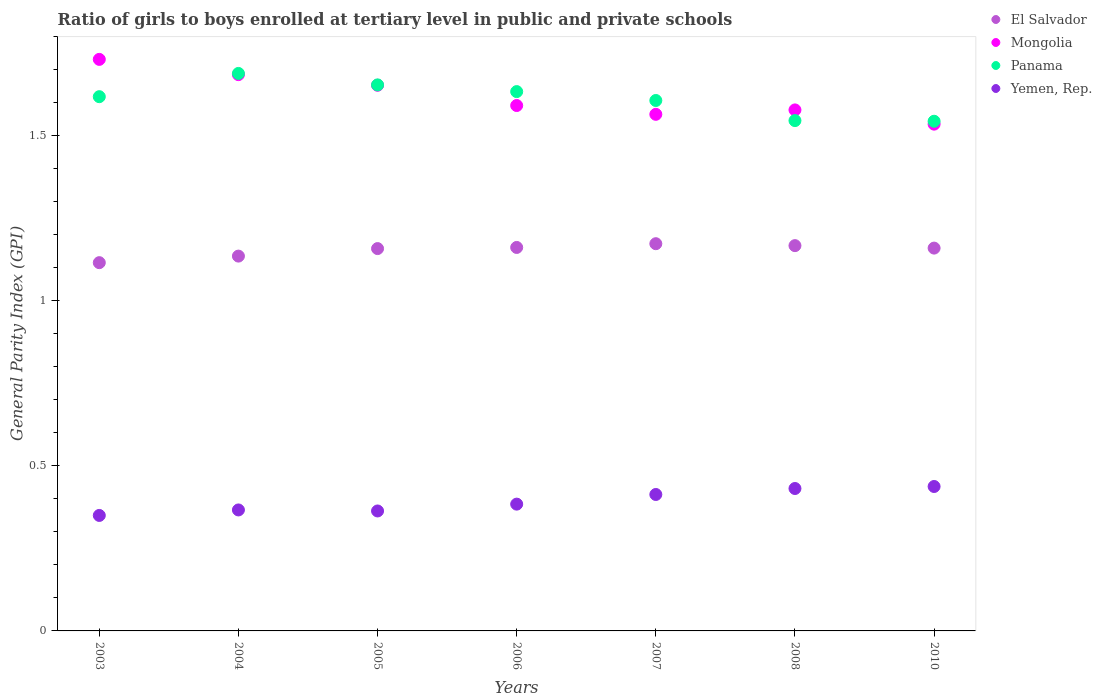How many different coloured dotlines are there?
Keep it short and to the point. 4. What is the general parity index in Panama in 2004?
Offer a terse response. 1.69. Across all years, what is the maximum general parity index in Panama?
Ensure brevity in your answer.  1.69. Across all years, what is the minimum general parity index in Panama?
Provide a short and direct response. 1.54. In which year was the general parity index in El Salvador maximum?
Keep it short and to the point. 2007. What is the total general parity index in Yemen, Rep. in the graph?
Offer a very short reply. 2.75. What is the difference between the general parity index in El Salvador in 2004 and that in 2010?
Offer a terse response. -0.02. What is the difference between the general parity index in Mongolia in 2006 and the general parity index in Panama in 2008?
Ensure brevity in your answer.  0.05. What is the average general parity index in Mongolia per year?
Your answer should be compact. 1.62. In the year 2006, what is the difference between the general parity index in Yemen, Rep. and general parity index in El Salvador?
Your answer should be compact. -0.78. In how many years, is the general parity index in El Salvador greater than 0.2?
Offer a very short reply. 7. What is the ratio of the general parity index in El Salvador in 2003 to that in 2007?
Provide a succinct answer. 0.95. Is the general parity index in Mongolia in 2004 less than that in 2008?
Your answer should be compact. No. What is the difference between the highest and the second highest general parity index in El Salvador?
Ensure brevity in your answer.  0.01. What is the difference between the highest and the lowest general parity index in Mongolia?
Keep it short and to the point. 0.2. Is the sum of the general parity index in El Salvador in 2004 and 2010 greater than the maximum general parity index in Mongolia across all years?
Your answer should be compact. Yes. Is the general parity index in Yemen, Rep. strictly less than the general parity index in El Salvador over the years?
Keep it short and to the point. Yes. How many dotlines are there?
Ensure brevity in your answer.  4. How many years are there in the graph?
Provide a short and direct response. 7. How many legend labels are there?
Provide a succinct answer. 4. How are the legend labels stacked?
Your response must be concise. Vertical. What is the title of the graph?
Your answer should be very brief. Ratio of girls to boys enrolled at tertiary level in public and private schools. Does "Liberia" appear as one of the legend labels in the graph?
Your answer should be compact. No. What is the label or title of the X-axis?
Make the answer very short. Years. What is the label or title of the Y-axis?
Offer a terse response. General Parity Index (GPI). What is the General Parity Index (GPI) of El Salvador in 2003?
Make the answer very short. 1.12. What is the General Parity Index (GPI) of Mongolia in 2003?
Offer a terse response. 1.73. What is the General Parity Index (GPI) of Panama in 2003?
Offer a terse response. 1.62. What is the General Parity Index (GPI) of Yemen, Rep. in 2003?
Make the answer very short. 0.35. What is the General Parity Index (GPI) in El Salvador in 2004?
Your answer should be compact. 1.14. What is the General Parity Index (GPI) in Mongolia in 2004?
Keep it short and to the point. 1.69. What is the General Parity Index (GPI) of Panama in 2004?
Give a very brief answer. 1.69. What is the General Parity Index (GPI) in Yemen, Rep. in 2004?
Provide a short and direct response. 0.37. What is the General Parity Index (GPI) of El Salvador in 2005?
Make the answer very short. 1.16. What is the General Parity Index (GPI) in Mongolia in 2005?
Offer a terse response. 1.65. What is the General Parity Index (GPI) in Panama in 2005?
Your answer should be very brief. 1.65. What is the General Parity Index (GPI) of Yemen, Rep. in 2005?
Your answer should be very brief. 0.36. What is the General Parity Index (GPI) of El Salvador in 2006?
Your answer should be compact. 1.16. What is the General Parity Index (GPI) in Mongolia in 2006?
Keep it short and to the point. 1.59. What is the General Parity Index (GPI) in Panama in 2006?
Give a very brief answer. 1.63. What is the General Parity Index (GPI) of Yemen, Rep. in 2006?
Your answer should be very brief. 0.38. What is the General Parity Index (GPI) in El Salvador in 2007?
Offer a very short reply. 1.17. What is the General Parity Index (GPI) in Mongolia in 2007?
Keep it short and to the point. 1.56. What is the General Parity Index (GPI) in Panama in 2007?
Your response must be concise. 1.61. What is the General Parity Index (GPI) in Yemen, Rep. in 2007?
Offer a terse response. 0.41. What is the General Parity Index (GPI) of El Salvador in 2008?
Offer a terse response. 1.17. What is the General Parity Index (GPI) of Mongolia in 2008?
Ensure brevity in your answer.  1.58. What is the General Parity Index (GPI) in Panama in 2008?
Provide a succinct answer. 1.55. What is the General Parity Index (GPI) in Yemen, Rep. in 2008?
Your answer should be compact. 0.43. What is the General Parity Index (GPI) in El Salvador in 2010?
Give a very brief answer. 1.16. What is the General Parity Index (GPI) in Mongolia in 2010?
Keep it short and to the point. 1.54. What is the General Parity Index (GPI) in Panama in 2010?
Your answer should be very brief. 1.54. What is the General Parity Index (GPI) in Yemen, Rep. in 2010?
Your answer should be very brief. 0.44. Across all years, what is the maximum General Parity Index (GPI) in El Salvador?
Provide a succinct answer. 1.17. Across all years, what is the maximum General Parity Index (GPI) in Mongolia?
Your answer should be very brief. 1.73. Across all years, what is the maximum General Parity Index (GPI) in Panama?
Keep it short and to the point. 1.69. Across all years, what is the maximum General Parity Index (GPI) in Yemen, Rep.?
Provide a short and direct response. 0.44. Across all years, what is the minimum General Parity Index (GPI) of El Salvador?
Offer a terse response. 1.12. Across all years, what is the minimum General Parity Index (GPI) in Mongolia?
Provide a short and direct response. 1.54. Across all years, what is the minimum General Parity Index (GPI) in Panama?
Your answer should be very brief. 1.54. Across all years, what is the minimum General Parity Index (GPI) of Yemen, Rep.?
Give a very brief answer. 0.35. What is the total General Parity Index (GPI) of El Salvador in the graph?
Make the answer very short. 8.07. What is the total General Parity Index (GPI) of Mongolia in the graph?
Make the answer very short. 11.34. What is the total General Parity Index (GPI) in Panama in the graph?
Offer a terse response. 11.29. What is the total General Parity Index (GPI) of Yemen, Rep. in the graph?
Offer a very short reply. 2.75. What is the difference between the General Parity Index (GPI) in El Salvador in 2003 and that in 2004?
Give a very brief answer. -0.02. What is the difference between the General Parity Index (GPI) of Mongolia in 2003 and that in 2004?
Keep it short and to the point. 0.05. What is the difference between the General Parity Index (GPI) in Panama in 2003 and that in 2004?
Your answer should be very brief. -0.07. What is the difference between the General Parity Index (GPI) in Yemen, Rep. in 2003 and that in 2004?
Provide a succinct answer. -0.02. What is the difference between the General Parity Index (GPI) in El Salvador in 2003 and that in 2005?
Keep it short and to the point. -0.04. What is the difference between the General Parity Index (GPI) in Mongolia in 2003 and that in 2005?
Give a very brief answer. 0.08. What is the difference between the General Parity Index (GPI) in Panama in 2003 and that in 2005?
Give a very brief answer. -0.04. What is the difference between the General Parity Index (GPI) of Yemen, Rep. in 2003 and that in 2005?
Keep it short and to the point. -0.01. What is the difference between the General Parity Index (GPI) of El Salvador in 2003 and that in 2006?
Give a very brief answer. -0.05. What is the difference between the General Parity Index (GPI) of Mongolia in 2003 and that in 2006?
Make the answer very short. 0.14. What is the difference between the General Parity Index (GPI) of Panama in 2003 and that in 2006?
Offer a terse response. -0.02. What is the difference between the General Parity Index (GPI) of Yemen, Rep. in 2003 and that in 2006?
Make the answer very short. -0.03. What is the difference between the General Parity Index (GPI) in El Salvador in 2003 and that in 2007?
Offer a terse response. -0.06. What is the difference between the General Parity Index (GPI) in Mongolia in 2003 and that in 2007?
Offer a terse response. 0.17. What is the difference between the General Parity Index (GPI) in Panama in 2003 and that in 2007?
Keep it short and to the point. 0.01. What is the difference between the General Parity Index (GPI) in Yemen, Rep. in 2003 and that in 2007?
Make the answer very short. -0.06. What is the difference between the General Parity Index (GPI) of El Salvador in 2003 and that in 2008?
Offer a terse response. -0.05. What is the difference between the General Parity Index (GPI) of Mongolia in 2003 and that in 2008?
Keep it short and to the point. 0.15. What is the difference between the General Parity Index (GPI) in Panama in 2003 and that in 2008?
Provide a succinct answer. 0.07. What is the difference between the General Parity Index (GPI) of Yemen, Rep. in 2003 and that in 2008?
Ensure brevity in your answer.  -0.08. What is the difference between the General Parity Index (GPI) in El Salvador in 2003 and that in 2010?
Your answer should be very brief. -0.04. What is the difference between the General Parity Index (GPI) of Mongolia in 2003 and that in 2010?
Keep it short and to the point. 0.2. What is the difference between the General Parity Index (GPI) of Panama in 2003 and that in 2010?
Offer a terse response. 0.07. What is the difference between the General Parity Index (GPI) of Yemen, Rep. in 2003 and that in 2010?
Keep it short and to the point. -0.09. What is the difference between the General Parity Index (GPI) of El Salvador in 2004 and that in 2005?
Offer a terse response. -0.02. What is the difference between the General Parity Index (GPI) of Mongolia in 2004 and that in 2005?
Offer a terse response. 0.03. What is the difference between the General Parity Index (GPI) of Panama in 2004 and that in 2005?
Your response must be concise. 0.03. What is the difference between the General Parity Index (GPI) of Yemen, Rep. in 2004 and that in 2005?
Offer a terse response. 0. What is the difference between the General Parity Index (GPI) in El Salvador in 2004 and that in 2006?
Keep it short and to the point. -0.03. What is the difference between the General Parity Index (GPI) in Mongolia in 2004 and that in 2006?
Your answer should be compact. 0.09. What is the difference between the General Parity Index (GPI) in Panama in 2004 and that in 2006?
Offer a very short reply. 0.06. What is the difference between the General Parity Index (GPI) in Yemen, Rep. in 2004 and that in 2006?
Ensure brevity in your answer.  -0.02. What is the difference between the General Parity Index (GPI) of El Salvador in 2004 and that in 2007?
Offer a very short reply. -0.04. What is the difference between the General Parity Index (GPI) in Mongolia in 2004 and that in 2007?
Ensure brevity in your answer.  0.12. What is the difference between the General Parity Index (GPI) in Panama in 2004 and that in 2007?
Your response must be concise. 0.08. What is the difference between the General Parity Index (GPI) of Yemen, Rep. in 2004 and that in 2007?
Offer a terse response. -0.05. What is the difference between the General Parity Index (GPI) of El Salvador in 2004 and that in 2008?
Your answer should be very brief. -0.03. What is the difference between the General Parity Index (GPI) in Mongolia in 2004 and that in 2008?
Offer a very short reply. 0.11. What is the difference between the General Parity Index (GPI) of Panama in 2004 and that in 2008?
Make the answer very short. 0.14. What is the difference between the General Parity Index (GPI) of Yemen, Rep. in 2004 and that in 2008?
Make the answer very short. -0.06. What is the difference between the General Parity Index (GPI) in El Salvador in 2004 and that in 2010?
Your response must be concise. -0.02. What is the difference between the General Parity Index (GPI) of Mongolia in 2004 and that in 2010?
Your response must be concise. 0.15. What is the difference between the General Parity Index (GPI) of Panama in 2004 and that in 2010?
Keep it short and to the point. 0.14. What is the difference between the General Parity Index (GPI) of Yemen, Rep. in 2004 and that in 2010?
Your response must be concise. -0.07. What is the difference between the General Parity Index (GPI) in El Salvador in 2005 and that in 2006?
Provide a succinct answer. -0. What is the difference between the General Parity Index (GPI) in Mongolia in 2005 and that in 2006?
Your response must be concise. 0.06. What is the difference between the General Parity Index (GPI) in Panama in 2005 and that in 2006?
Your answer should be compact. 0.02. What is the difference between the General Parity Index (GPI) in Yemen, Rep. in 2005 and that in 2006?
Your answer should be very brief. -0.02. What is the difference between the General Parity Index (GPI) of El Salvador in 2005 and that in 2007?
Ensure brevity in your answer.  -0.01. What is the difference between the General Parity Index (GPI) of Mongolia in 2005 and that in 2007?
Offer a terse response. 0.09. What is the difference between the General Parity Index (GPI) in Panama in 2005 and that in 2007?
Offer a very short reply. 0.05. What is the difference between the General Parity Index (GPI) of Yemen, Rep. in 2005 and that in 2007?
Your response must be concise. -0.05. What is the difference between the General Parity Index (GPI) of El Salvador in 2005 and that in 2008?
Ensure brevity in your answer.  -0.01. What is the difference between the General Parity Index (GPI) of Mongolia in 2005 and that in 2008?
Provide a short and direct response. 0.07. What is the difference between the General Parity Index (GPI) in Panama in 2005 and that in 2008?
Keep it short and to the point. 0.11. What is the difference between the General Parity Index (GPI) in Yemen, Rep. in 2005 and that in 2008?
Your answer should be compact. -0.07. What is the difference between the General Parity Index (GPI) of El Salvador in 2005 and that in 2010?
Make the answer very short. -0. What is the difference between the General Parity Index (GPI) in Mongolia in 2005 and that in 2010?
Give a very brief answer. 0.12. What is the difference between the General Parity Index (GPI) in Panama in 2005 and that in 2010?
Ensure brevity in your answer.  0.11. What is the difference between the General Parity Index (GPI) of Yemen, Rep. in 2005 and that in 2010?
Offer a terse response. -0.07. What is the difference between the General Parity Index (GPI) in El Salvador in 2006 and that in 2007?
Give a very brief answer. -0.01. What is the difference between the General Parity Index (GPI) in Mongolia in 2006 and that in 2007?
Give a very brief answer. 0.03. What is the difference between the General Parity Index (GPI) of Panama in 2006 and that in 2007?
Offer a very short reply. 0.03. What is the difference between the General Parity Index (GPI) of Yemen, Rep. in 2006 and that in 2007?
Your response must be concise. -0.03. What is the difference between the General Parity Index (GPI) in El Salvador in 2006 and that in 2008?
Provide a succinct answer. -0.01. What is the difference between the General Parity Index (GPI) in Mongolia in 2006 and that in 2008?
Your answer should be compact. 0.01. What is the difference between the General Parity Index (GPI) in Panama in 2006 and that in 2008?
Offer a terse response. 0.09. What is the difference between the General Parity Index (GPI) of Yemen, Rep. in 2006 and that in 2008?
Ensure brevity in your answer.  -0.05. What is the difference between the General Parity Index (GPI) of El Salvador in 2006 and that in 2010?
Make the answer very short. 0. What is the difference between the General Parity Index (GPI) in Mongolia in 2006 and that in 2010?
Offer a terse response. 0.06. What is the difference between the General Parity Index (GPI) of Panama in 2006 and that in 2010?
Give a very brief answer. 0.09. What is the difference between the General Parity Index (GPI) in Yemen, Rep. in 2006 and that in 2010?
Your answer should be compact. -0.05. What is the difference between the General Parity Index (GPI) in El Salvador in 2007 and that in 2008?
Ensure brevity in your answer.  0.01. What is the difference between the General Parity Index (GPI) of Mongolia in 2007 and that in 2008?
Provide a short and direct response. -0.01. What is the difference between the General Parity Index (GPI) of Panama in 2007 and that in 2008?
Offer a terse response. 0.06. What is the difference between the General Parity Index (GPI) in Yemen, Rep. in 2007 and that in 2008?
Provide a succinct answer. -0.02. What is the difference between the General Parity Index (GPI) in El Salvador in 2007 and that in 2010?
Provide a succinct answer. 0.01. What is the difference between the General Parity Index (GPI) in Mongolia in 2007 and that in 2010?
Provide a succinct answer. 0.03. What is the difference between the General Parity Index (GPI) in Panama in 2007 and that in 2010?
Provide a short and direct response. 0.06. What is the difference between the General Parity Index (GPI) of Yemen, Rep. in 2007 and that in 2010?
Your answer should be very brief. -0.02. What is the difference between the General Parity Index (GPI) in El Salvador in 2008 and that in 2010?
Offer a terse response. 0.01. What is the difference between the General Parity Index (GPI) of Mongolia in 2008 and that in 2010?
Offer a very short reply. 0.04. What is the difference between the General Parity Index (GPI) in Panama in 2008 and that in 2010?
Offer a terse response. 0. What is the difference between the General Parity Index (GPI) of Yemen, Rep. in 2008 and that in 2010?
Provide a short and direct response. -0.01. What is the difference between the General Parity Index (GPI) of El Salvador in 2003 and the General Parity Index (GPI) of Mongolia in 2004?
Give a very brief answer. -0.57. What is the difference between the General Parity Index (GPI) of El Salvador in 2003 and the General Parity Index (GPI) of Panama in 2004?
Offer a very short reply. -0.57. What is the difference between the General Parity Index (GPI) of El Salvador in 2003 and the General Parity Index (GPI) of Yemen, Rep. in 2004?
Provide a succinct answer. 0.75. What is the difference between the General Parity Index (GPI) of Mongolia in 2003 and the General Parity Index (GPI) of Panama in 2004?
Offer a terse response. 0.04. What is the difference between the General Parity Index (GPI) of Mongolia in 2003 and the General Parity Index (GPI) of Yemen, Rep. in 2004?
Your answer should be compact. 1.36. What is the difference between the General Parity Index (GPI) in Panama in 2003 and the General Parity Index (GPI) in Yemen, Rep. in 2004?
Offer a very short reply. 1.25. What is the difference between the General Parity Index (GPI) of El Salvador in 2003 and the General Parity Index (GPI) of Mongolia in 2005?
Offer a very short reply. -0.54. What is the difference between the General Parity Index (GPI) of El Salvador in 2003 and the General Parity Index (GPI) of Panama in 2005?
Your response must be concise. -0.54. What is the difference between the General Parity Index (GPI) of El Salvador in 2003 and the General Parity Index (GPI) of Yemen, Rep. in 2005?
Your answer should be very brief. 0.75. What is the difference between the General Parity Index (GPI) in Mongolia in 2003 and the General Parity Index (GPI) in Panama in 2005?
Provide a succinct answer. 0.08. What is the difference between the General Parity Index (GPI) of Mongolia in 2003 and the General Parity Index (GPI) of Yemen, Rep. in 2005?
Give a very brief answer. 1.37. What is the difference between the General Parity Index (GPI) in Panama in 2003 and the General Parity Index (GPI) in Yemen, Rep. in 2005?
Your answer should be compact. 1.25. What is the difference between the General Parity Index (GPI) in El Salvador in 2003 and the General Parity Index (GPI) in Mongolia in 2006?
Keep it short and to the point. -0.48. What is the difference between the General Parity Index (GPI) of El Salvador in 2003 and the General Parity Index (GPI) of Panama in 2006?
Ensure brevity in your answer.  -0.52. What is the difference between the General Parity Index (GPI) in El Salvador in 2003 and the General Parity Index (GPI) in Yemen, Rep. in 2006?
Your answer should be compact. 0.73. What is the difference between the General Parity Index (GPI) in Mongolia in 2003 and the General Parity Index (GPI) in Panama in 2006?
Your answer should be very brief. 0.1. What is the difference between the General Parity Index (GPI) of Mongolia in 2003 and the General Parity Index (GPI) of Yemen, Rep. in 2006?
Your response must be concise. 1.35. What is the difference between the General Parity Index (GPI) in Panama in 2003 and the General Parity Index (GPI) in Yemen, Rep. in 2006?
Provide a succinct answer. 1.23. What is the difference between the General Parity Index (GPI) in El Salvador in 2003 and the General Parity Index (GPI) in Mongolia in 2007?
Your answer should be very brief. -0.45. What is the difference between the General Parity Index (GPI) in El Salvador in 2003 and the General Parity Index (GPI) in Panama in 2007?
Your answer should be very brief. -0.49. What is the difference between the General Parity Index (GPI) of El Salvador in 2003 and the General Parity Index (GPI) of Yemen, Rep. in 2007?
Give a very brief answer. 0.7. What is the difference between the General Parity Index (GPI) of Mongolia in 2003 and the General Parity Index (GPI) of Panama in 2007?
Offer a terse response. 0.12. What is the difference between the General Parity Index (GPI) in Mongolia in 2003 and the General Parity Index (GPI) in Yemen, Rep. in 2007?
Your answer should be very brief. 1.32. What is the difference between the General Parity Index (GPI) of Panama in 2003 and the General Parity Index (GPI) of Yemen, Rep. in 2007?
Provide a succinct answer. 1.21. What is the difference between the General Parity Index (GPI) of El Salvador in 2003 and the General Parity Index (GPI) of Mongolia in 2008?
Your response must be concise. -0.46. What is the difference between the General Parity Index (GPI) of El Salvador in 2003 and the General Parity Index (GPI) of Panama in 2008?
Offer a very short reply. -0.43. What is the difference between the General Parity Index (GPI) of El Salvador in 2003 and the General Parity Index (GPI) of Yemen, Rep. in 2008?
Offer a terse response. 0.68. What is the difference between the General Parity Index (GPI) in Mongolia in 2003 and the General Parity Index (GPI) in Panama in 2008?
Ensure brevity in your answer.  0.19. What is the difference between the General Parity Index (GPI) of Mongolia in 2003 and the General Parity Index (GPI) of Yemen, Rep. in 2008?
Your response must be concise. 1.3. What is the difference between the General Parity Index (GPI) in Panama in 2003 and the General Parity Index (GPI) in Yemen, Rep. in 2008?
Provide a short and direct response. 1.19. What is the difference between the General Parity Index (GPI) of El Salvador in 2003 and the General Parity Index (GPI) of Mongolia in 2010?
Offer a terse response. -0.42. What is the difference between the General Parity Index (GPI) of El Salvador in 2003 and the General Parity Index (GPI) of Panama in 2010?
Give a very brief answer. -0.43. What is the difference between the General Parity Index (GPI) of El Salvador in 2003 and the General Parity Index (GPI) of Yemen, Rep. in 2010?
Your response must be concise. 0.68. What is the difference between the General Parity Index (GPI) of Mongolia in 2003 and the General Parity Index (GPI) of Panama in 2010?
Give a very brief answer. 0.19. What is the difference between the General Parity Index (GPI) of Mongolia in 2003 and the General Parity Index (GPI) of Yemen, Rep. in 2010?
Your response must be concise. 1.29. What is the difference between the General Parity Index (GPI) of Panama in 2003 and the General Parity Index (GPI) of Yemen, Rep. in 2010?
Give a very brief answer. 1.18. What is the difference between the General Parity Index (GPI) of El Salvador in 2004 and the General Parity Index (GPI) of Mongolia in 2005?
Offer a terse response. -0.52. What is the difference between the General Parity Index (GPI) of El Salvador in 2004 and the General Parity Index (GPI) of Panama in 2005?
Ensure brevity in your answer.  -0.52. What is the difference between the General Parity Index (GPI) of El Salvador in 2004 and the General Parity Index (GPI) of Yemen, Rep. in 2005?
Your answer should be compact. 0.77. What is the difference between the General Parity Index (GPI) in Mongolia in 2004 and the General Parity Index (GPI) in Panama in 2005?
Ensure brevity in your answer.  0.03. What is the difference between the General Parity Index (GPI) of Mongolia in 2004 and the General Parity Index (GPI) of Yemen, Rep. in 2005?
Offer a very short reply. 1.32. What is the difference between the General Parity Index (GPI) in Panama in 2004 and the General Parity Index (GPI) in Yemen, Rep. in 2005?
Your response must be concise. 1.33. What is the difference between the General Parity Index (GPI) in El Salvador in 2004 and the General Parity Index (GPI) in Mongolia in 2006?
Offer a terse response. -0.46. What is the difference between the General Parity Index (GPI) of El Salvador in 2004 and the General Parity Index (GPI) of Panama in 2006?
Make the answer very short. -0.5. What is the difference between the General Parity Index (GPI) of El Salvador in 2004 and the General Parity Index (GPI) of Yemen, Rep. in 2006?
Offer a very short reply. 0.75. What is the difference between the General Parity Index (GPI) of Mongolia in 2004 and the General Parity Index (GPI) of Panama in 2006?
Keep it short and to the point. 0.05. What is the difference between the General Parity Index (GPI) of Mongolia in 2004 and the General Parity Index (GPI) of Yemen, Rep. in 2006?
Provide a succinct answer. 1.3. What is the difference between the General Parity Index (GPI) of Panama in 2004 and the General Parity Index (GPI) of Yemen, Rep. in 2006?
Keep it short and to the point. 1.3. What is the difference between the General Parity Index (GPI) in El Salvador in 2004 and the General Parity Index (GPI) in Mongolia in 2007?
Keep it short and to the point. -0.43. What is the difference between the General Parity Index (GPI) of El Salvador in 2004 and the General Parity Index (GPI) of Panama in 2007?
Your answer should be compact. -0.47. What is the difference between the General Parity Index (GPI) of El Salvador in 2004 and the General Parity Index (GPI) of Yemen, Rep. in 2007?
Offer a terse response. 0.72. What is the difference between the General Parity Index (GPI) in Mongolia in 2004 and the General Parity Index (GPI) in Panama in 2007?
Your response must be concise. 0.08. What is the difference between the General Parity Index (GPI) in Mongolia in 2004 and the General Parity Index (GPI) in Yemen, Rep. in 2007?
Offer a terse response. 1.27. What is the difference between the General Parity Index (GPI) of Panama in 2004 and the General Parity Index (GPI) of Yemen, Rep. in 2007?
Provide a succinct answer. 1.28. What is the difference between the General Parity Index (GPI) in El Salvador in 2004 and the General Parity Index (GPI) in Mongolia in 2008?
Provide a short and direct response. -0.44. What is the difference between the General Parity Index (GPI) of El Salvador in 2004 and the General Parity Index (GPI) of Panama in 2008?
Your answer should be compact. -0.41. What is the difference between the General Parity Index (GPI) in El Salvador in 2004 and the General Parity Index (GPI) in Yemen, Rep. in 2008?
Make the answer very short. 0.7. What is the difference between the General Parity Index (GPI) in Mongolia in 2004 and the General Parity Index (GPI) in Panama in 2008?
Ensure brevity in your answer.  0.14. What is the difference between the General Parity Index (GPI) of Mongolia in 2004 and the General Parity Index (GPI) of Yemen, Rep. in 2008?
Make the answer very short. 1.25. What is the difference between the General Parity Index (GPI) in Panama in 2004 and the General Parity Index (GPI) in Yemen, Rep. in 2008?
Give a very brief answer. 1.26. What is the difference between the General Parity Index (GPI) in El Salvador in 2004 and the General Parity Index (GPI) in Mongolia in 2010?
Keep it short and to the point. -0.4. What is the difference between the General Parity Index (GPI) of El Salvador in 2004 and the General Parity Index (GPI) of Panama in 2010?
Offer a very short reply. -0.41. What is the difference between the General Parity Index (GPI) of El Salvador in 2004 and the General Parity Index (GPI) of Yemen, Rep. in 2010?
Your response must be concise. 0.7. What is the difference between the General Parity Index (GPI) in Mongolia in 2004 and the General Parity Index (GPI) in Panama in 2010?
Your response must be concise. 0.14. What is the difference between the General Parity Index (GPI) in Mongolia in 2004 and the General Parity Index (GPI) in Yemen, Rep. in 2010?
Keep it short and to the point. 1.25. What is the difference between the General Parity Index (GPI) in Panama in 2004 and the General Parity Index (GPI) in Yemen, Rep. in 2010?
Offer a very short reply. 1.25. What is the difference between the General Parity Index (GPI) in El Salvador in 2005 and the General Parity Index (GPI) in Mongolia in 2006?
Your response must be concise. -0.43. What is the difference between the General Parity Index (GPI) of El Salvador in 2005 and the General Parity Index (GPI) of Panama in 2006?
Keep it short and to the point. -0.48. What is the difference between the General Parity Index (GPI) in El Salvador in 2005 and the General Parity Index (GPI) in Yemen, Rep. in 2006?
Offer a terse response. 0.77. What is the difference between the General Parity Index (GPI) in Mongolia in 2005 and the General Parity Index (GPI) in Panama in 2006?
Make the answer very short. 0.02. What is the difference between the General Parity Index (GPI) of Mongolia in 2005 and the General Parity Index (GPI) of Yemen, Rep. in 2006?
Keep it short and to the point. 1.27. What is the difference between the General Parity Index (GPI) of Panama in 2005 and the General Parity Index (GPI) of Yemen, Rep. in 2006?
Offer a very short reply. 1.27. What is the difference between the General Parity Index (GPI) of El Salvador in 2005 and the General Parity Index (GPI) of Mongolia in 2007?
Your answer should be very brief. -0.41. What is the difference between the General Parity Index (GPI) in El Salvador in 2005 and the General Parity Index (GPI) in Panama in 2007?
Offer a terse response. -0.45. What is the difference between the General Parity Index (GPI) in El Salvador in 2005 and the General Parity Index (GPI) in Yemen, Rep. in 2007?
Ensure brevity in your answer.  0.74. What is the difference between the General Parity Index (GPI) of Mongolia in 2005 and the General Parity Index (GPI) of Panama in 2007?
Your answer should be compact. 0.05. What is the difference between the General Parity Index (GPI) of Mongolia in 2005 and the General Parity Index (GPI) of Yemen, Rep. in 2007?
Make the answer very short. 1.24. What is the difference between the General Parity Index (GPI) in Panama in 2005 and the General Parity Index (GPI) in Yemen, Rep. in 2007?
Offer a terse response. 1.24. What is the difference between the General Parity Index (GPI) in El Salvador in 2005 and the General Parity Index (GPI) in Mongolia in 2008?
Give a very brief answer. -0.42. What is the difference between the General Parity Index (GPI) of El Salvador in 2005 and the General Parity Index (GPI) of Panama in 2008?
Your answer should be very brief. -0.39. What is the difference between the General Parity Index (GPI) of El Salvador in 2005 and the General Parity Index (GPI) of Yemen, Rep. in 2008?
Offer a very short reply. 0.73. What is the difference between the General Parity Index (GPI) in Mongolia in 2005 and the General Parity Index (GPI) in Panama in 2008?
Provide a succinct answer. 0.11. What is the difference between the General Parity Index (GPI) in Mongolia in 2005 and the General Parity Index (GPI) in Yemen, Rep. in 2008?
Provide a succinct answer. 1.22. What is the difference between the General Parity Index (GPI) in Panama in 2005 and the General Parity Index (GPI) in Yemen, Rep. in 2008?
Keep it short and to the point. 1.22. What is the difference between the General Parity Index (GPI) of El Salvador in 2005 and the General Parity Index (GPI) of Mongolia in 2010?
Provide a succinct answer. -0.38. What is the difference between the General Parity Index (GPI) in El Salvador in 2005 and the General Parity Index (GPI) in Panama in 2010?
Ensure brevity in your answer.  -0.39. What is the difference between the General Parity Index (GPI) in El Salvador in 2005 and the General Parity Index (GPI) in Yemen, Rep. in 2010?
Make the answer very short. 0.72. What is the difference between the General Parity Index (GPI) in Mongolia in 2005 and the General Parity Index (GPI) in Panama in 2010?
Your answer should be compact. 0.11. What is the difference between the General Parity Index (GPI) in Mongolia in 2005 and the General Parity Index (GPI) in Yemen, Rep. in 2010?
Your answer should be compact. 1.22. What is the difference between the General Parity Index (GPI) in Panama in 2005 and the General Parity Index (GPI) in Yemen, Rep. in 2010?
Your answer should be compact. 1.22. What is the difference between the General Parity Index (GPI) in El Salvador in 2006 and the General Parity Index (GPI) in Mongolia in 2007?
Keep it short and to the point. -0.4. What is the difference between the General Parity Index (GPI) in El Salvador in 2006 and the General Parity Index (GPI) in Panama in 2007?
Make the answer very short. -0.45. What is the difference between the General Parity Index (GPI) in El Salvador in 2006 and the General Parity Index (GPI) in Yemen, Rep. in 2007?
Ensure brevity in your answer.  0.75. What is the difference between the General Parity Index (GPI) in Mongolia in 2006 and the General Parity Index (GPI) in Panama in 2007?
Your answer should be compact. -0.02. What is the difference between the General Parity Index (GPI) of Mongolia in 2006 and the General Parity Index (GPI) of Yemen, Rep. in 2007?
Give a very brief answer. 1.18. What is the difference between the General Parity Index (GPI) of Panama in 2006 and the General Parity Index (GPI) of Yemen, Rep. in 2007?
Keep it short and to the point. 1.22. What is the difference between the General Parity Index (GPI) in El Salvador in 2006 and the General Parity Index (GPI) in Mongolia in 2008?
Your response must be concise. -0.42. What is the difference between the General Parity Index (GPI) of El Salvador in 2006 and the General Parity Index (GPI) of Panama in 2008?
Make the answer very short. -0.38. What is the difference between the General Parity Index (GPI) of El Salvador in 2006 and the General Parity Index (GPI) of Yemen, Rep. in 2008?
Provide a short and direct response. 0.73. What is the difference between the General Parity Index (GPI) of Mongolia in 2006 and the General Parity Index (GPI) of Panama in 2008?
Provide a short and direct response. 0.05. What is the difference between the General Parity Index (GPI) in Mongolia in 2006 and the General Parity Index (GPI) in Yemen, Rep. in 2008?
Offer a very short reply. 1.16. What is the difference between the General Parity Index (GPI) of Panama in 2006 and the General Parity Index (GPI) of Yemen, Rep. in 2008?
Offer a terse response. 1.2. What is the difference between the General Parity Index (GPI) in El Salvador in 2006 and the General Parity Index (GPI) in Mongolia in 2010?
Give a very brief answer. -0.37. What is the difference between the General Parity Index (GPI) in El Salvador in 2006 and the General Parity Index (GPI) in Panama in 2010?
Your answer should be compact. -0.38. What is the difference between the General Parity Index (GPI) in El Salvador in 2006 and the General Parity Index (GPI) in Yemen, Rep. in 2010?
Your answer should be compact. 0.72. What is the difference between the General Parity Index (GPI) in Mongolia in 2006 and the General Parity Index (GPI) in Panama in 2010?
Keep it short and to the point. 0.05. What is the difference between the General Parity Index (GPI) in Mongolia in 2006 and the General Parity Index (GPI) in Yemen, Rep. in 2010?
Your response must be concise. 1.15. What is the difference between the General Parity Index (GPI) of Panama in 2006 and the General Parity Index (GPI) of Yemen, Rep. in 2010?
Provide a succinct answer. 1.2. What is the difference between the General Parity Index (GPI) of El Salvador in 2007 and the General Parity Index (GPI) of Mongolia in 2008?
Your answer should be very brief. -0.41. What is the difference between the General Parity Index (GPI) of El Salvador in 2007 and the General Parity Index (GPI) of Panama in 2008?
Offer a very short reply. -0.37. What is the difference between the General Parity Index (GPI) in El Salvador in 2007 and the General Parity Index (GPI) in Yemen, Rep. in 2008?
Your answer should be compact. 0.74. What is the difference between the General Parity Index (GPI) in Mongolia in 2007 and the General Parity Index (GPI) in Panama in 2008?
Your answer should be very brief. 0.02. What is the difference between the General Parity Index (GPI) in Mongolia in 2007 and the General Parity Index (GPI) in Yemen, Rep. in 2008?
Your response must be concise. 1.13. What is the difference between the General Parity Index (GPI) in Panama in 2007 and the General Parity Index (GPI) in Yemen, Rep. in 2008?
Your response must be concise. 1.18. What is the difference between the General Parity Index (GPI) of El Salvador in 2007 and the General Parity Index (GPI) of Mongolia in 2010?
Offer a very short reply. -0.36. What is the difference between the General Parity Index (GPI) in El Salvador in 2007 and the General Parity Index (GPI) in Panama in 2010?
Ensure brevity in your answer.  -0.37. What is the difference between the General Parity Index (GPI) in El Salvador in 2007 and the General Parity Index (GPI) in Yemen, Rep. in 2010?
Provide a short and direct response. 0.74. What is the difference between the General Parity Index (GPI) of Mongolia in 2007 and the General Parity Index (GPI) of Panama in 2010?
Your response must be concise. 0.02. What is the difference between the General Parity Index (GPI) of Mongolia in 2007 and the General Parity Index (GPI) of Yemen, Rep. in 2010?
Your answer should be compact. 1.13. What is the difference between the General Parity Index (GPI) of Panama in 2007 and the General Parity Index (GPI) of Yemen, Rep. in 2010?
Provide a succinct answer. 1.17. What is the difference between the General Parity Index (GPI) in El Salvador in 2008 and the General Parity Index (GPI) in Mongolia in 2010?
Provide a short and direct response. -0.37. What is the difference between the General Parity Index (GPI) of El Salvador in 2008 and the General Parity Index (GPI) of Panama in 2010?
Provide a short and direct response. -0.38. What is the difference between the General Parity Index (GPI) of El Salvador in 2008 and the General Parity Index (GPI) of Yemen, Rep. in 2010?
Your response must be concise. 0.73. What is the difference between the General Parity Index (GPI) of Mongolia in 2008 and the General Parity Index (GPI) of Panama in 2010?
Ensure brevity in your answer.  0.03. What is the difference between the General Parity Index (GPI) of Mongolia in 2008 and the General Parity Index (GPI) of Yemen, Rep. in 2010?
Make the answer very short. 1.14. What is the difference between the General Parity Index (GPI) in Panama in 2008 and the General Parity Index (GPI) in Yemen, Rep. in 2010?
Make the answer very short. 1.11. What is the average General Parity Index (GPI) in El Salvador per year?
Offer a terse response. 1.15. What is the average General Parity Index (GPI) of Mongolia per year?
Keep it short and to the point. 1.62. What is the average General Parity Index (GPI) of Panama per year?
Make the answer very short. 1.61. What is the average General Parity Index (GPI) of Yemen, Rep. per year?
Provide a succinct answer. 0.39. In the year 2003, what is the difference between the General Parity Index (GPI) of El Salvador and General Parity Index (GPI) of Mongolia?
Offer a very short reply. -0.62. In the year 2003, what is the difference between the General Parity Index (GPI) in El Salvador and General Parity Index (GPI) in Panama?
Offer a very short reply. -0.5. In the year 2003, what is the difference between the General Parity Index (GPI) of El Salvador and General Parity Index (GPI) of Yemen, Rep.?
Offer a terse response. 0.77. In the year 2003, what is the difference between the General Parity Index (GPI) of Mongolia and General Parity Index (GPI) of Panama?
Ensure brevity in your answer.  0.11. In the year 2003, what is the difference between the General Parity Index (GPI) in Mongolia and General Parity Index (GPI) in Yemen, Rep.?
Offer a terse response. 1.38. In the year 2003, what is the difference between the General Parity Index (GPI) of Panama and General Parity Index (GPI) of Yemen, Rep.?
Your answer should be very brief. 1.27. In the year 2004, what is the difference between the General Parity Index (GPI) of El Salvador and General Parity Index (GPI) of Mongolia?
Your answer should be compact. -0.55. In the year 2004, what is the difference between the General Parity Index (GPI) in El Salvador and General Parity Index (GPI) in Panama?
Your response must be concise. -0.55. In the year 2004, what is the difference between the General Parity Index (GPI) in El Salvador and General Parity Index (GPI) in Yemen, Rep.?
Your answer should be very brief. 0.77. In the year 2004, what is the difference between the General Parity Index (GPI) in Mongolia and General Parity Index (GPI) in Panama?
Your response must be concise. -0. In the year 2004, what is the difference between the General Parity Index (GPI) in Mongolia and General Parity Index (GPI) in Yemen, Rep.?
Your answer should be very brief. 1.32. In the year 2004, what is the difference between the General Parity Index (GPI) of Panama and General Parity Index (GPI) of Yemen, Rep.?
Keep it short and to the point. 1.32. In the year 2005, what is the difference between the General Parity Index (GPI) of El Salvador and General Parity Index (GPI) of Mongolia?
Provide a short and direct response. -0.49. In the year 2005, what is the difference between the General Parity Index (GPI) in El Salvador and General Parity Index (GPI) in Panama?
Make the answer very short. -0.5. In the year 2005, what is the difference between the General Parity Index (GPI) of El Salvador and General Parity Index (GPI) of Yemen, Rep.?
Make the answer very short. 0.79. In the year 2005, what is the difference between the General Parity Index (GPI) of Mongolia and General Parity Index (GPI) of Panama?
Your response must be concise. -0. In the year 2005, what is the difference between the General Parity Index (GPI) of Mongolia and General Parity Index (GPI) of Yemen, Rep.?
Provide a succinct answer. 1.29. In the year 2005, what is the difference between the General Parity Index (GPI) of Panama and General Parity Index (GPI) of Yemen, Rep.?
Make the answer very short. 1.29. In the year 2006, what is the difference between the General Parity Index (GPI) in El Salvador and General Parity Index (GPI) in Mongolia?
Offer a terse response. -0.43. In the year 2006, what is the difference between the General Parity Index (GPI) of El Salvador and General Parity Index (GPI) of Panama?
Provide a succinct answer. -0.47. In the year 2006, what is the difference between the General Parity Index (GPI) in El Salvador and General Parity Index (GPI) in Yemen, Rep.?
Offer a very short reply. 0.78. In the year 2006, what is the difference between the General Parity Index (GPI) of Mongolia and General Parity Index (GPI) of Panama?
Your response must be concise. -0.04. In the year 2006, what is the difference between the General Parity Index (GPI) in Mongolia and General Parity Index (GPI) in Yemen, Rep.?
Provide a short and direct response. 1.21. In the year 2006, what is the difference between the General Parity Index (GPI) in Panama and General Parity Index (GPI) in Yemen, Rep.?
Your answer should be compact. 1.25. In the year 2007, what is the difference between the General Parity Index (GPI) in El Salvador and General Parity Index (GPI) in Mongolia?
Keep it short and to the point. -0.39. In the year 2007, what is the difference between the General Parity Index (GPI) of El Salvador and General Parity Index (GPI) of Panama?
Give a very brief answer. -0.43. In the year 2007, what is the difference between the General Parity Index (GPI) in El Salvador and General Parity Index (GPI) in Yemen, Rep.?
Offer a very short reply. 0.76. In the year 2007, what is the difference between the General Parity Index (GPI) of Mongolia and General Parity Index (GPI) of Panama?
Your answer should be very brief. -0.04. In the year 2007, what is the difference between the General Parity Index (GPI) in Mongolia and General Parity Index (GPI) in Yemen, Rep.?
Ensure brevity in your answer.  1.15. In the year 2007, what is the difference between the General Parity Index (GPI) in Panama and General Parity Index (GPI) in Yemen, Rep.?
Make the answer very short. 1.19. In the year 2008, what is the difference between the General Parity Index (GPI) in El Salvador and General Parity Index (GPI) in Mongolia?
Ensure brevity in your answer.  -0.41. In the year 2008, what is the difference between the General Parity Index (GPI) in El Salvador and General Parity Index (GPI) in Panama?
Ensure brevity in your answer.  -0.38. In the year 2008, what is the difference between the General Parity Index (GPI) of El Salvador and General Parity Index (GPI) of Yemen, Rep.?
Offer a very short reply. 0.74. In the year 2008, what is the difference between the General Parity Index (GPI) of Mongolia and General Parity Index (GPI) of Panama?
Your answer should be compact. 0.03. In the year 2008, what is the difference between the General Parity Index (GPI) of Mongolia and General Parity Index (GPI) of Yemen, Rep.?
Your answer should be compact. 1.15. In the year 2008, what is the difference between the General Parity Index (GPI) of Panama and General Parity Index (GPI) of Yemen, Rep.?
Offer a terse response. 1.11. In the year 2010, what is the difference between the General Parity Index (GPI) in El Salvador and General Parity Index (GPI) in Mongolia?
Offer a very short reply. -0.38. In the year 2010, what is the difference between the General Parity Index (GPI) in El Salvador and General Parity Index (GPI) in Panama?
Keep it short and to the point. -0.38. In the year 2010, what is the difference between the General Parity Index (GPI) in El Salvador and General Parity Index (GPI) in Yemen, Rep.?
Provide a short and direct response. 0.72. In the year 2010, what is the difference between the General Parity Index (GPI) in Mongolia and General Parity Index (GPI) in Panama?
Ensure brevity in your answer.  -0.01. In the year 2010, what is the difference between the General Parity Index (GPI) of Mongolia and General Parity Index (GPI) of Yemen, Rep.?
Keep it short and to the point. 1.1. In the year 2010, what is the difference between the General Parity Index (GPI) in Panama and General Parity Index (GPI) in Yemen, Rep.?
Offer a terse response. 1.11. What is the ratio of the General Parity Index (GPI) in El Salvador in 2003 to that in 2004?
Offer a very short reply. 0.98. What is the ratio of the General Parity Index (GPI) of Mongolia in 2003 to that in 2004?
Offer a terse response. 1.03. What is the ratio of the General Parity Index (GPI) of Yemen, Rep. in 2003 to that in 2004?
Offer a very short reply. 0.95. What is the ratio of the General Parity Index (GPI) in El Salvador in 2003 to that in 2005?
Your response must be concise. 0.96. What is the ratio of the General Parity Index (GPI) in Mongolia in 2003 to that in 2005?
Your answer should be very brief. 1.05. What is the ratio of the General Parity Index (GPI) of Panama in 2003 to that in 2005?
Provide a short and direct response. 0.98. What is the ratio of the General Parity Index (GPI) in Yemen, Rep. in 2003 to that in 2005?
Make the answer very short. 0.96. What is the ratio of the General Parity Index (GPI) of El Salvador in 2003 to that in 2006?
Your answer should be compact. 0.96. What is the ratio of the General Parity Index (GPI) in Mongolia in 2003 to that in 2006?
Provide a short and direct response. 1.09. What is the ratio of the General Parity Index (GPI) in Panama in 2003 to that in 2006?
Offer a very short reply. 0.99. What is the ratio of the General Parity Index (GPI) of Yemen, Rep. in 2003 to that in 2006?
Offer a very short reply. 0.91. What is the ratio of the General Parity Index (GPI) in El Salvador in 2003 to that in 2007?
Your answer should be very brief. 0.95. What is the ratio of the General Parity Index (GPI) in Mongolia in 2003 to that in 2007?
Offer a terse response. 1.11. What is the ratio of the General Parity Index (GPI) of Yemen, Rep. in 2003 to that in 2007?
Provide a succinct answer. 0.85. What is the ratio of the General Parity Index (GPI) of El Salvador in 2003 to that in 2008?
Provide a succinct answer. 0.96. What is the ratio of the General Parity Index (GPI) of Mongolia in 2003 to that in 2008?
Ensure brevity in your answer.  1.1. What is the ratio of the General Parity Index (GPI) in Panama in 2003 to that in 2008?
Provide a succinct answer. 1.05. What is the ratio of the General Parity Index (GPI) in Yemen, Rep. in 2003 to that in 2008?
Your answer should be compact. 0.81. What is the ratio of the General Parity Index (GPI) in El Salvador in 2003 to that in 2010?
Provide a succinct answer. 0.96. What is the ratio of the General Parity Index (GPI) in Mongolia in 2003 to that in 2010?
Your answer should be very brief. 1.13. What is the ratio of the General Parity Index (GPI) in Panama in 2003 to that in 2010?
Make the answer very short. 1.05. What is the ratio of the General Parity Index (GPI) of Yemen, Rep. in 2003 to that in 2010?
Ensure brevity in your answer.  0.8. What is the ratio of the General Parity Index (GPI) in El Salvador in 2004 to that in 2005?
Make the answer very short. 0.98. What is the ratio of the General Parity Index (GPI) in Mongolia in 2004 to that in 2005?
Your answer should be very brief. 1.02. What is the ratio of the General Parity Index (GPI) of Yemen, Rep. in 2004 to that in 2005?
Provide a succinct answer. 1.01. What is the ratio of the General Parity Index (GPI) of El Salvador in 2004 to that in 2006?
Provide a short and direct response. 0.98. What is the ratio of the General Parity Index (GPI) of Mongolia in 2004 to that in 2006?
Provide a short and direct response. 1.06. What is the ratio of the General Parity Index (GPI) of Panama in 2004 to that in 2006?
Provide a short and direct response. 1.03. What is the ratio of the General Parity Index (GPI) in Yemen, Rep. in 2004 to that in 2006?
Your answer should be very brief. 0.95. What is the ratio of the General Parity Index (GPI) in Mongolia in 2004 to that in 2007?
Your response must be concise. 1.08. What is the ratio of the General Parity Index (GPI) of Panama in 2004 to that in 2007?
Make the answer very short. 1.05. What is the ratio of the General Parity Index (GPI) of Yemen, Rep. in 2004 to that in 2007?
Provide a succinct answer. 0.89. What is the ratio of the General Parity Index (GPI) in El Salvador in 2004 to that in 2008?
Your answer should be very brief. 0.97. What is the ratio of the General Parity Index (GPI) in Mongolia in 2004 to that in 2008?
Provide a short and direct response. 1.07. What is the ratio of the General Parity Index (GPI) in Panama in 2004 to that in 2008?
Provide a short and direct response. 1.09. What is the ratio of the General Parity Index (GPI) in Yemen, Rep. in 2004 to that in 2008?
Your answer should be very brief. 0.85. What is the ratio of the General Parity Index (GPI) of El Salvador in 2004 to that in 2010?
Offer a terse response. 0.98. What is the ratio of the General Parity Index (GPI) of Mongolia in 2004 to that in 2010?
Your answer should be compact. 1.1. What is the ratio of the General Parity Index (GPI) of Panama in 2004 to that in 2010?
Make the answer very short. 1.09. What is the ratio of the General Parity Index (GPI) of Yemen, Rep. in 2004 to that in 2010?
Offer a terse response. 0.84. What is the ratio of the General Parity Index (GPI) of Panama in 2005 to that in 2006?
Make the answer very short. 1.01. What is the ratio of the General Parity Index (GPI) of Yemen, Rep. in 2005 to that in 2006?
Give a very brief answer. 0.95. What is the ratio of the General Parity Index (GPI) of El Salvador in 2005 to that in 2007?
Keep it short and to the point. 0.99. What is the ratio of the General Parity Index (GPI) of Mongolia in 2005 to that in 2007?
Your answer should be compact. 1.06. What is the ratio of the General Parity Index (GPI) in Panama in 2005 to that in 2007?
Ensure brevity in your answer.  1.03. What is the ratio of the General Parity Index (GPI) of Yemen, Rep. in 2005 to that in 2007?
Give a very brief answer. 0.88. What is the ratio of the General Parity Index (GPI) in Mongolia in 2005 to that in 2008?
Your response must be concise. 1.05. What is the ratio of the General Parity Index (GPI) in Panama in 2005 to that in 2008?
Give a very brief answer. 1.07. What is the ratio of the General Parity Index (GPI) of Yemen, Rep. in 2005 to that in 2008?
Make the answer very short. 0.84. What is the ratio of the General Parity Index (GPI) in Mongolia in 2005 to that in 2010?
Provide a short and direct response. 1.08. What is the ratio of the General Parity Index (GPI) in Panama in 2005 to that in 2010?
Your response must be concise. 1.07. What is the ratio of the General Parity Index (GPI) in Yemen, Rep. in 2005 to that in 2010?
Your answer should be compact. 0.83. What is the ratio of the General Parity Index (GPI) in El Salvador in 2006 to that in 2007?
Provide a succinct answer. 0.99. What is the ratio of the General Parity Index (GPI) of Mongolia in 2006 to that in 2007?
Your answer should be very brief. 1.02. What is the ratio of the General Parity Index (GPI) of Panama in 2006 to that in 2007?
Your response must be concise. 1.02. What is the ratio of the General Parity Index (GPI) in Yemen, Rep. in 2006 to that in 2007?
Keep it short and to the point. 0.93. What is the ratio of the General Parity Index (GPI) of Mongolia in 2006 to that in 2008?
Provide a short and direct response. 1.01. What is the ratio of the General Parity Index (GPI) in Panama in 2006 to that in 2008?
Provide a short and direct response. 1.06. What is the ratio of the General Parity Index (GPI) in Yemen, Rep. in 2006 to that in 2008?
Ensure brevity in your answer.  0.89. What is the ratio of the General Parity Index (GPI) of Mongolia in 2006 to that in 2010?
Give a very brief answer. 1.04. What is the ratio of the General Parity Index (GPI) in Panama in 2006 to that in 2010?
Ensure brevity in your answer.  1.06. What is the ratio of the General Parity Index (GPI) in Yemen, Rep. in 2006 to that in 2010?
Offer a terse response. 0.88. What is the ratio of the General Parity Index (GPI) of Mongolia in 2007 to that in 2008?
Provide a short and direct response. 0.99. What is the ratio of the General Parity Index (GPI) of Panama in 2007 to that in 2008?
Offer a terse response. 1.04. What is the ratio of the General Parity Index (GPI) in Yemen, Rep. in 2007 to that in 2008?
Ensure brevity in your answer.  0.96. What is the ratio of the General Parity Index (GPI) of El Salvador in 2007 to that in 2010?
Offer a very short reply. 1.01. What is the ratio of the General Parity Index (GPI) in Mongolia in 2007 to that in 2010?
Make the answer very short. 1.02. What is the ratio of the General Parity Index (GPI) of Panama in 2007 to that in 2010?
Provide a short and direct response. 1.04. What is the ratio of the General Parity Index (GPI) of Yemen, Rep. in 2007 to that in 2010?
Give a very brief answer. 0.94. What is the ratio of the General Parity Index (GPI) of Mongolia in 2008 to that in 2010?
Your answer should be compact. 1.03. What is the ratio of the General Parity Index (GPI) of Yemen, Rep. in 2008 to that in 2010?
Ensure brevity in your answer.  0.99. What is the difference between the highest and the second highest General Parity Index (GPI) in El Salvador?
Make the answer very short. 0.01. What is the difference between the highest and the second highest General Parity Index (GPI) of Mongolia?
Your answer should be very brief. 0.05. What is the difference between the highest and the second highest General Parity Index (GPI) of Panama?
Provide a short and direct response. 0.03. What is the difference between the highest and the second highest General Parity Index (GPI) of Yemen, Rep.?
Provide a succinct answer. 0.01. What is the difference between the highest and the lowest General Parity Index (GPI) of El Salvador?
Your response must be concise. 0.06. What is the difference between the highest and the lowest General Parity Index (GPI) of Mongolia?
Your answer should be compact. 0.2. What is the difference between the highest and the lowest General Parity Index (GPI) in Panama?
Your answer should be very brief. 0.14. What is the difference between the highest and the lowest General Parity Index (GPI) in Yemen, Rep.?
Keep it short and to the point. 0.09. 